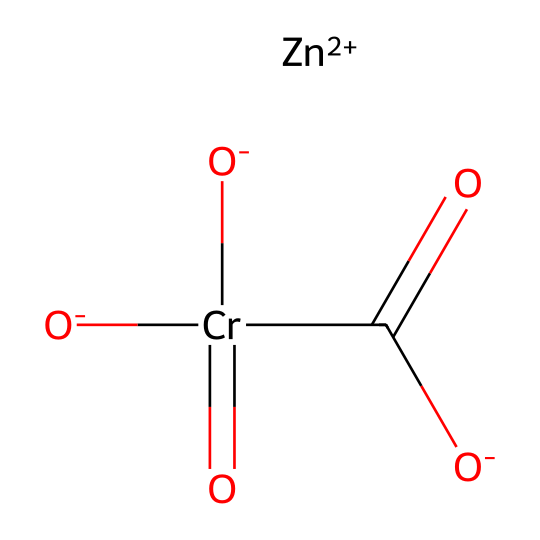What is the central metal atom in this coordination compound? The SMILES representation indicates the presence of [Zn+2], which denotes that zinc is the central metal ion surrounded by the ligands.
Answer: zinc How many oxygen atoms are present in the coordination compound? By analyzing the SMILES, we can count three oxygen atoms associated with the chromium and one oxygen in the carboxylate, totaling four oxygen atoms.
Answer: four What type of ligand is involved in this coordination compound? The SMILES shows [O-]C(=O), which indicates a carboxylate (functional group) is acting as a bidentate ligand in coordination with the metal.
Answer: carboxylate What is the coordination number of the central metal? There are four ligands attached to the zinc ion when considering all oxygens from the carboxylate and the other coordination, resulting in a coordination number of four.
Answer: four Which metal is in its +2 oxidation state in this compound? The presence of [Zn+2] in the SMILES representation shows that zinc is explicitly stated to be in the +2 oxidation state.
Answer: zinc What is the oxidation state of chromium in this compound? In the SMILES representation, chromium is shown with three oxygen anions and two double-bonded oxo groups; analyzing these suggests that chromium is in the +6 oxidation state.
Answer: +6 What is the main function of the coordination compound in heat-resistant paints? Coordination compounds like the one represented help enhance thermal stability and adhesion properties of the paints, which are crucial for resisting high temperatures.
Answer: thermal stability 